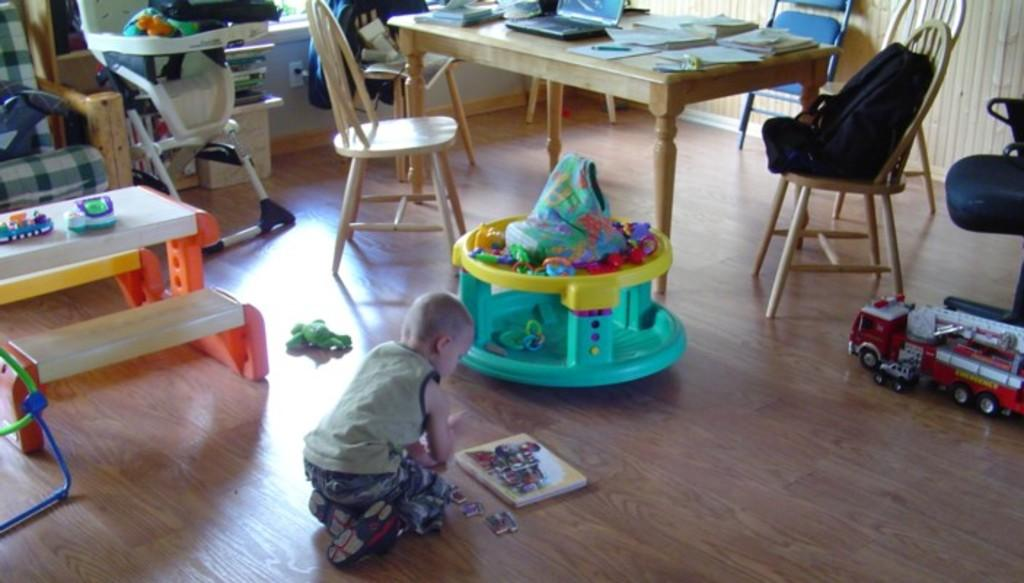Who is present in the image? There is a boy in the image. What is the boy doing in the image? The boy is playing with toys in the image. What type of furniture can be seen in the image? There are chairs in the image. What electronic device is on the table? There is a laptop on the table in the image. What else is on the table besides the laptop? There are papers on the table in the image. What type of mobility aid is in the image? There is a walker in the image. What type of drum is the boy playing in the image? There is no drum present in the image; the boy is playing with toys. 